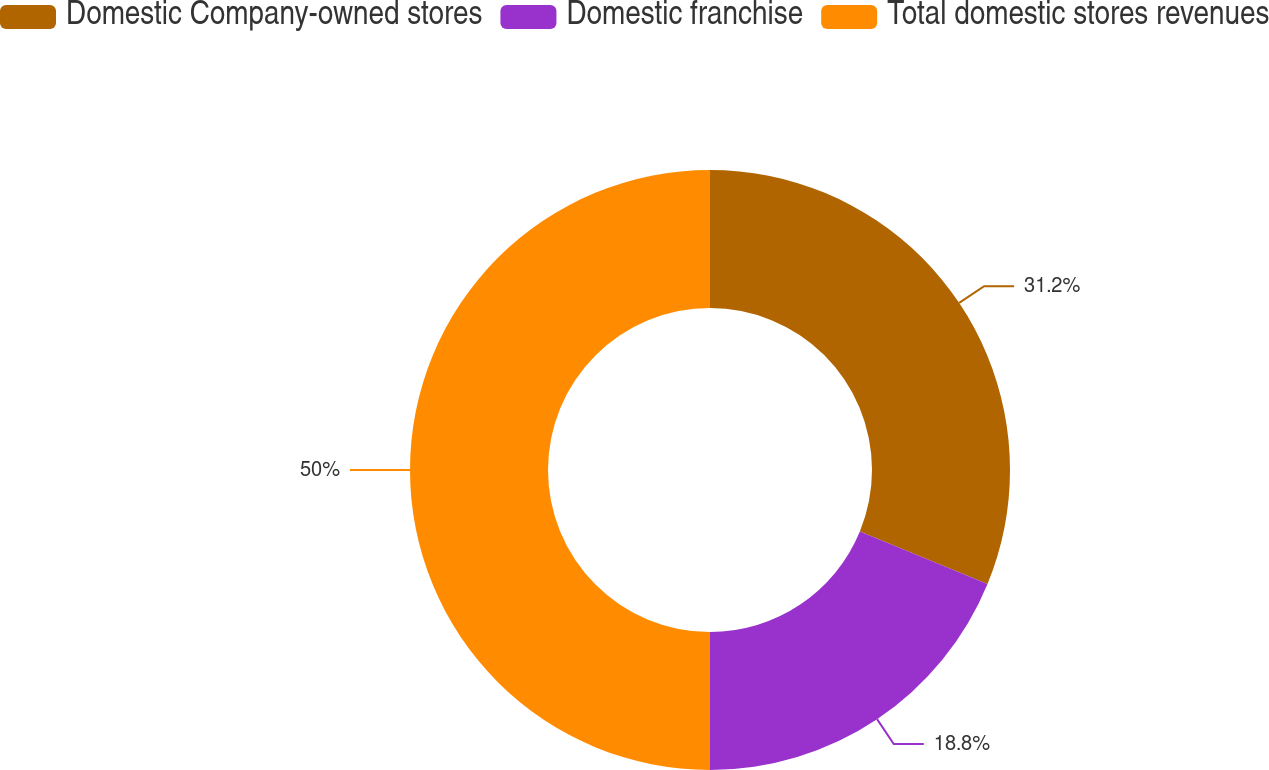Convert chart. <chart><loc_0><loc_0><loc_500><loc_500><pie_chart><fcel>Domestic Company-owned stores<fcel>Domestic franchise<fcel>Total domestic stores revenues<nl><fcel>31.2%<fcel>18.8%<fcel>50.0%<nl></chart> 